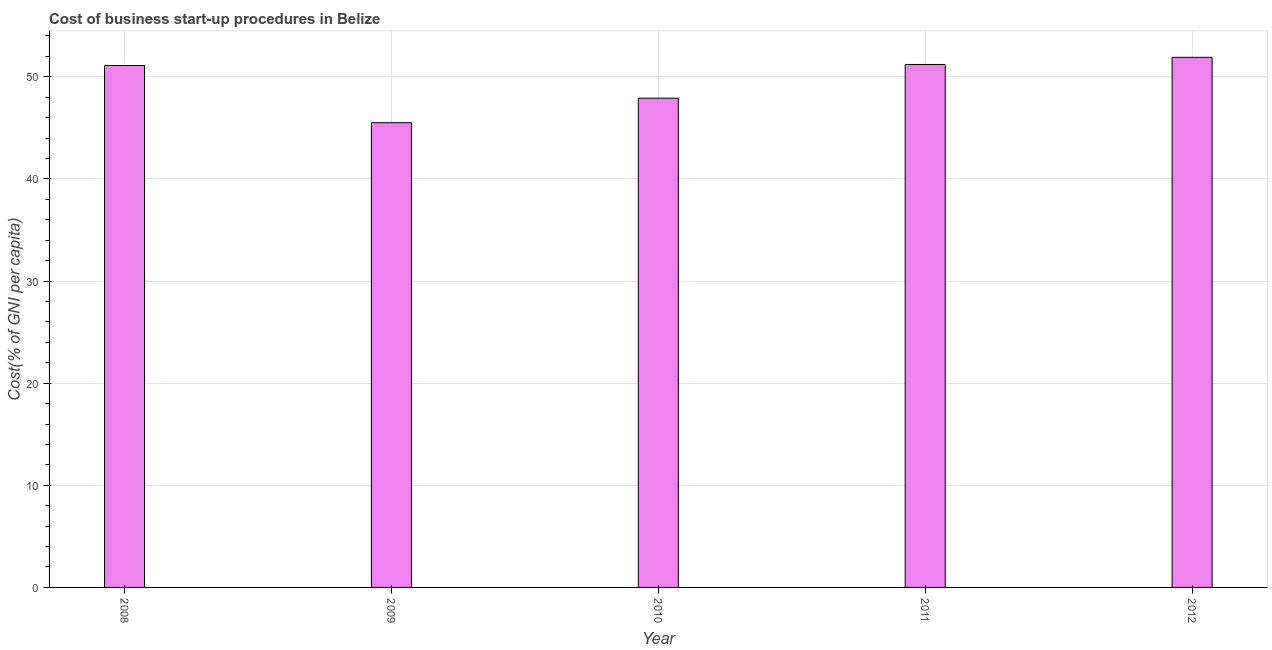What is the title of the graph?
Give a very brief answer. Cost of business start-up procedures in Belize. What is the label or title of the Y-axis?
Your answer should be very brief. Cost(% of GNI per capita). What is the cost of business startup procedures in 2008?
Keep it short and to the point. 51.1. Across all years, what is the maximum cost of business startup procedures?
Ensure brevity in your answer.  51.9. Across all years, what is the minimum cost of business startup procedures?
Your response must be concise. 45.5. In which year was the cost of business startup procedures maximum?
Your answer should be very brief. 2012. What is the sum of the cost of business startup procedures?
Your answer should be compact. 247.6. What is the difference between the cost of business startup procedures in 2009 and 2011?
Keep it short and to the point. -5.7. What is the average cost of business startup procedures per year?
Your answer should be very brief. 49.52. What is the median cost of business startup procedures?
Provide a succinct answer. 51.1. Do a majority of the years between 2011 and 2010 (inclusive) have cost of business startup procedures greater than 26 %?
Provide a succinct answer. No. Is the sum of the cost of business startup procedures in 2010 and 2011 greater than the maximum cost of business startup procedures across all years?
Offer a very short reply. Yes. How many bars are there?
Ensure brevity in your answer.  5. What is the difference between two consecutive major ticks on the Y-axis?
Keep it short and to the point. 10. Are the values on the major ticks of Y-axis written in scientific E-notation?
Provide a short and direct response. No. What is the Cost(% of GNI per capita) of 2008?
Offer a terse response. 51.1. What is the Cost(% of GNI per capita) in 2009?
Your answer should be compact. 45.5. What is the Cost(% of GNI per capita) in 2010?
Provide a short and direct response. 47.9. What is the Cost(% of GNI per capita) of 2011?
Your answer should be very brief. 51.2. What is the Cost(% of GNI per capita) in 2012?
Offer a terse response. 51.9. What is the difference between the Cost(% of GNI per capita) in 2008 and 2010?
Give a very brief answer. 3.2. What is the difference between the Cost(% of GNI per capita) in 2009 and 2010?
Make the answer very short. -2.4. What is the difference between the Cost(% of GNI per capita) in 2009 and 2011?
Ensure brevity in your answer.  -5.7. What is the difference between the Cost(% of GNI per capita) in 2010 and 2012?
Offer a terse response. -4. What is the difference between the Cost(% of GNI per capita) in 2011 and 2012?
Offer a terse response. -0.7. What is the ratio of the Cost(% of GNI per capita) in 2008 to that in 2009?
Give a very brief answer. 1.12. What is the ratio of the Cost(% of GNI per capita) in 2008 to that in 2010?
Your answer should be compact. 1.07. What is the ratio of the Cost(% of GNI per capita) in 2008 to that in 2011?
Your answer should be compact. 1. What is the ratio of the Cost(% of GNI per capita) in 2009 to that in 2010?
Offer a terse response. 0.95. What is the ratio of the Cost(% of GNI per capita) in 2009 to that in 2011?
Your answer should be very brief. 0.89. What is the ratio of the Cost(% of GNI per capita) in 2009 to that in 2012?
Give a very brief answer. 0.88. What is the ratio of the Cost(% of GNI per capita) in 2010 to that in 2011?
Keep it short and to the point. 0.94. What is the ratio of the Cost(% of GNI per capita) in 2010 to that in 2012?
Your answer should be compact. 0.92. What is the ratio of the Cost(% of GNI per capita) in 2011 to that in 2012?
Offer a very short reply. 0.99. 